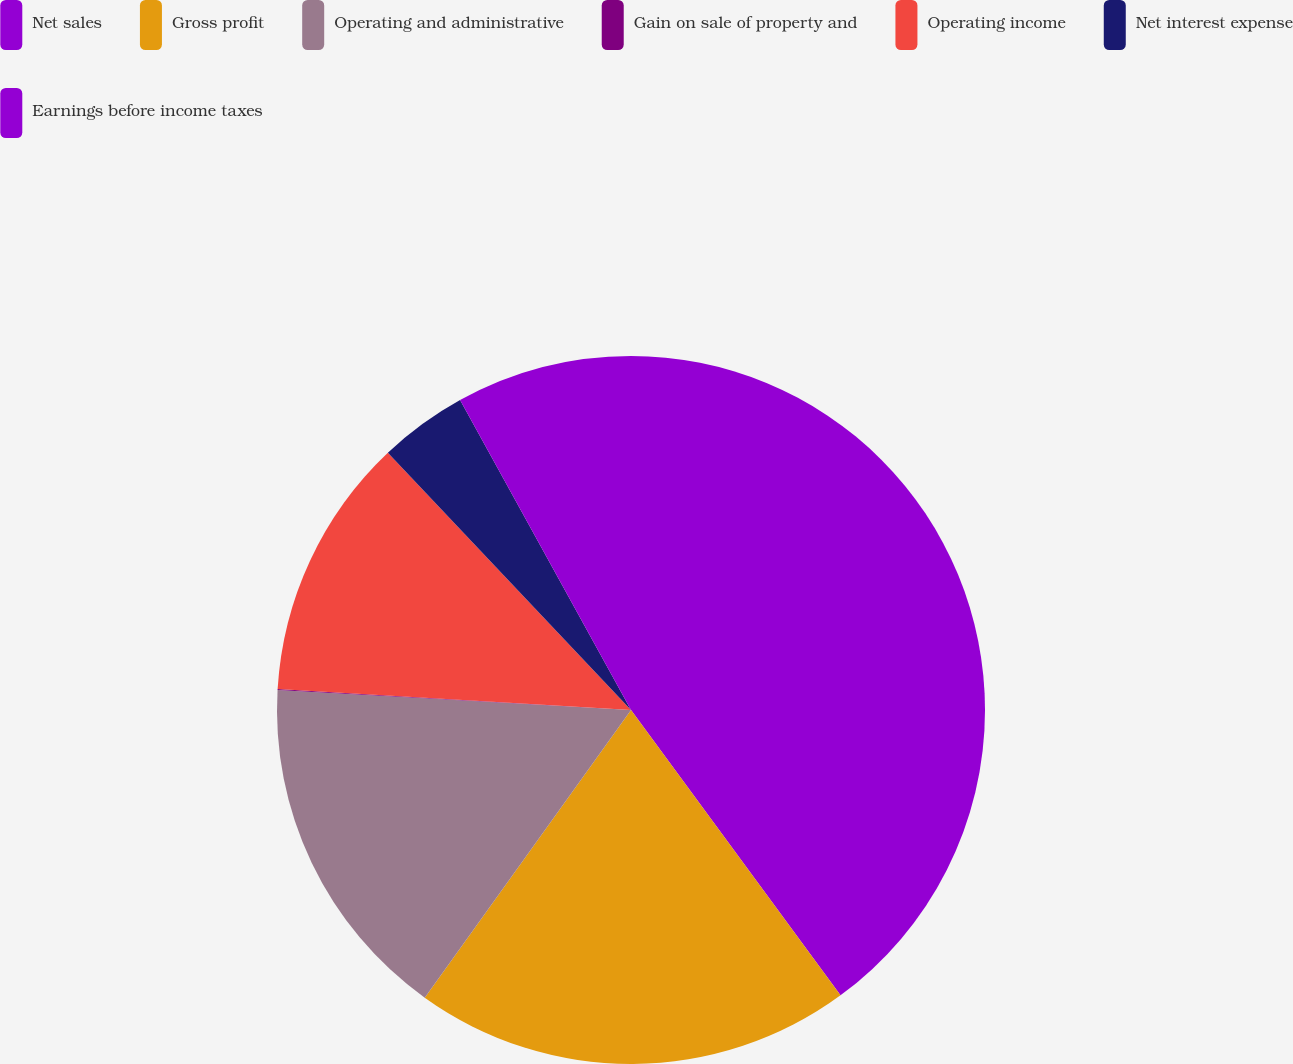Convert chart. <chart><loc_0><loc_0><loc_500><loc_500><pie_chart><fcel>Net sales<fcel>Gross profit<fcel>Operating and administrative<fcel>Gain on sale of property and<fcel>Operating income<fcel>Net interest expense<fcel>Earnings before income taxes<nl><fcel>39.92%<fcel>19.98%<fcel>16.0%<fcel>0.04%<fcel>12.01%<fcel>4.03%<fcel>8.02%<nl></chart> 